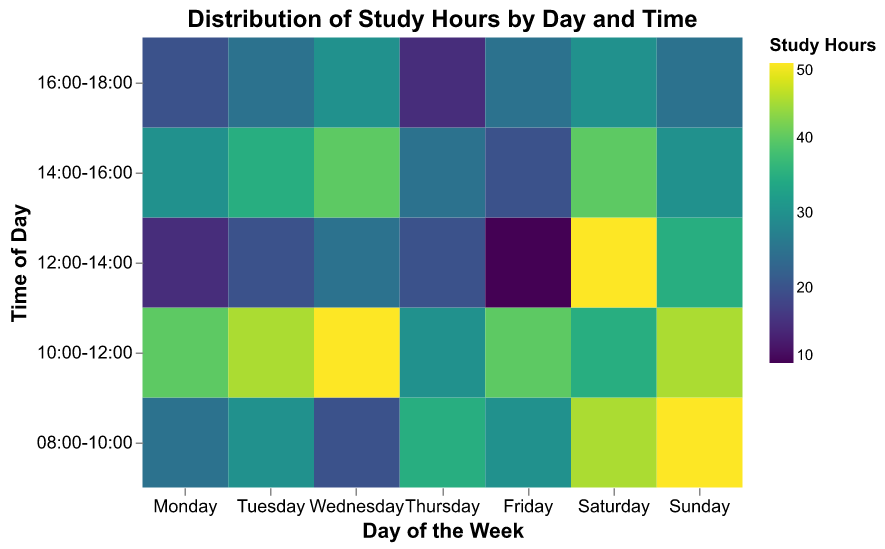What is the title of the heatmap? The title is displayed at the top of the heatmap. It reads "Distribution of Study Hours by Day and Time" in bold and larger font.
Answer: Distribution of Study Hours by Day and Time Which day has the highest total study hours in the time range 08:00-10:00? By examining the color intensity (where darker indicates more hours), Sunday shows the darkest shade for the 08:00-10:00 time slot, indicating it has the highest study hours.
Answer: Sunday What is the least studied time slot on Thursday? On Thursday, the lightest color appears in the 16:00-18:00 time slot, signifying the least study hours.
Answer: 16:00-18:00 Which time slot on Wednesday has the highest study hours? By scanning across Wednesday, the 10:00-12:00 time slot stands out with the darkest color, indicating the highest study hours.
Answer: 10:00-12:00 How do study hours on Saturday from 12:00-14:00 compare to Friday from 12:00-14:00? Comparing the color shades, Saturday's 12:00-14:00 time slot is significantly darker than Friday's, implying more study hours on Saturday.
Answer: More on Saturday On which day/time is the study hours distribution the most evenly spread? Looking at the color intensity on each day, Monday shows varying shades, but none are extremely dark or light, indicating a more even spread of study hours across different times.
Answer: Monday What is the period with the highest concentration of study hours in the weekend? Observing the combined darker shades across Saturday and Sunday, the 12:00-14:00 time slot stands out as it is quite dark on both days.
Answer: 12:00-14:00 How do the study hours from 08:00-10:00 on Tuesday compare to those on Wednesday? The colors indicate that Tuesday's 08:00-10:00 slot is darker than Wednesday's, meaning more study hours on Tuesday within that range.
Answer: More on Tuesday Which day has the most varied levels of study hours across all time slots? Looking at the color variations across the days, Sunday has the highest range of colors from dark to light, indicating the most varied study hours.
Answer: Sunday 